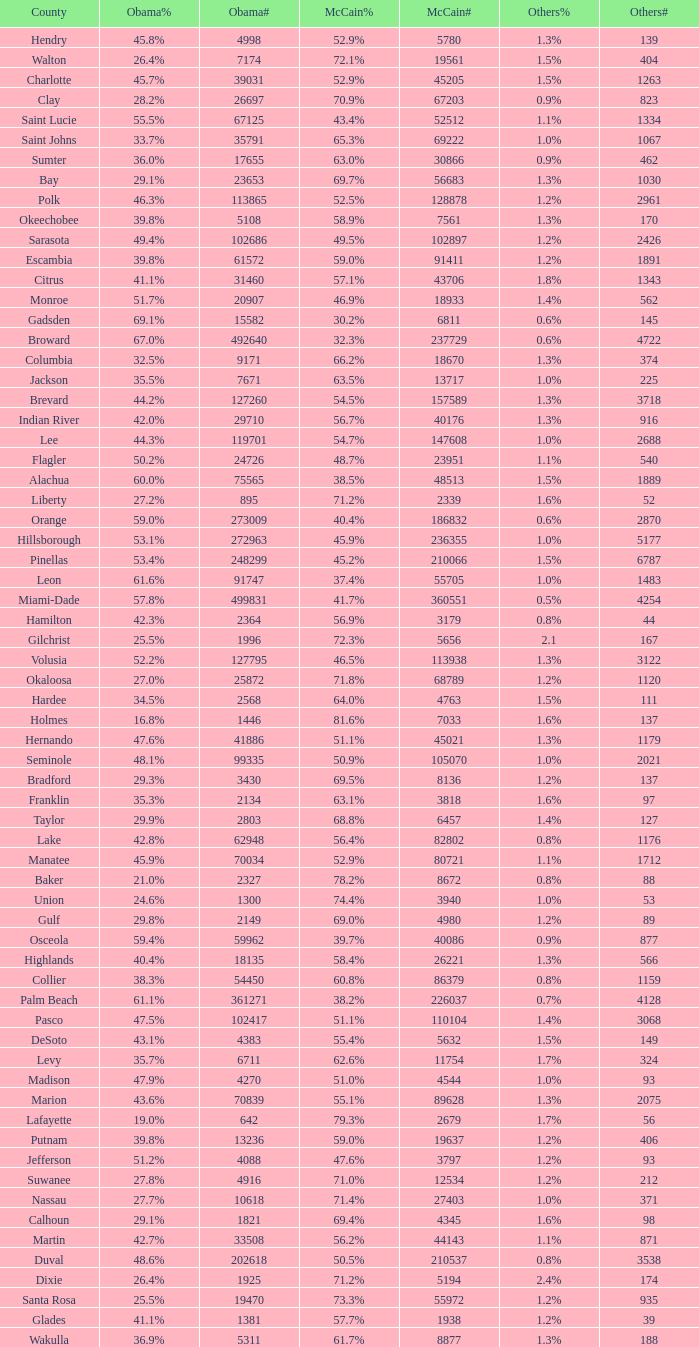What was the number of others votes in Columbia county? 374.0. Could you help me parse every detail presented in this table? {'header': ['County', 'Obama%', 'Obama#', 'McCain%', 'McCain#', 'Others%', 'Others#'], 'rows': [['Hendry', '45.8%', '4998', '52.9%', '5780', '1.3%', '139'], ['Walton', '26.4%', '7174', '72.1%', '19561', '1.5%', '404'], ['Charlotte', '45.7%', '39031', '52.9%', '45205', '1.5%', '1263'], ['Clay', '28.2%', '26697', '70.9%', '67203', '0.9%', '823'], ['Saint Lucie', '55.5%', '67125', '43.4%', '52512', '1.1%', '1334'], ['Saint Johns', '33.7%', '35791', '65.3%', '69222', '1.0%', '1067'], ['Sumter', '36.0%', '17655', '63.0%', '30866', '0.9%', '462'], ['Bay', '29.1%', '23653', '69.7%', '56683', '1.3%', '1030'], ['Polk', '46.3%', '113865', '52.5%', '128878', '1.2%', '2961'], ['Okeechobee', '39.8%', '5108', '58.9%', '7561', '1.3%', '170'], ['Sarasota', '49.4%', '102686', '49.5%', '102897', '1.2%', '2426'], ['Escambia', '39.8%', '61572', '59.0%', '91411', '1.2%', '1891'], ['Citrus', '41.1%', '31460', '57.1%', '43706', '1.8%', '1343'], ['Monroe', '51.7%', '20907', '46.9%', '18933', '1.4%', '562'], ['Gadsden', '69.1%', '15582', '30.2%', '6811', '0.6%', '145'], ['Broward', '67.0%', '492640', '32.3%', '237729', '0.6%', '4722'], ['Columbia', '32.5%', '9171', '66.2%', '18670', '1.3%', '374'], ['Jackson', '35.5%', '7671', '63.5%', '13717', '1.0%', '225'], ['Brevard', '44.2%', '127260', '54.5%', '157589', '1.3%', '3718'], ['Indian River', '42.0%', '29710', '56.7%', '40176', '1.3%', '916'], ['Lee', '44.3%', '119701', '54.7%', '147608', '1.0%', '2688'], ['Flagler', '50.2%', '24726', '48.7%', '23951', '1.1%', '540'], ['Alachua', '60.0%', '75565', '38.5%', '48513', '1.5%', '1889'], ['Liberty', '27.2%', '895', '71.2%', '2339', '1.6%', '52'], ['Orange', '59.0%', '273009', '40.4%', '186832', '0.6%', '2870'], ['Hillsborough', '53.1%', '272963', '45.9%', '236355', '1.0%', '5177'], ['Pinellas', '53.4%', '248299', '45.2%', '210066', '1.5%', '6787'], ['Leon', '61.6%', '91747', '37.4%', '55705', '1.0%', '1483'], ['Miami-Dade', '57.8%', '499831', '41.7%', '360551', '0.5%', '4254'], ['Hamilton', '42.3%', '2364', '56.9%', '3179', '0.8%', '44'], ['Gilchrist', '25.5%', '1996', '72.3%', '5656', '2.1', '167'], ['Volusia', '52.2%', '127795', '46.5%', '113938', '1.3%', '3122'], ['Okaloosa', '27.0%', '25872', '71.8%', '68789', '1.2%', '1120'], ['Hardee', '34.5%', '2568', '64.0%', '4763', '1.5%', '111'], ['Holmes', '16.8%', '1446', '81.6%', '7033', '1.6%', '137'], ['Hernando', '47.6%', '41886', '51.1%', '45021', '1.3%', '1179'], ['Seminole', '48.1%', '99335', '50.9%', '105070', '1.0%', '2021'], ['Bradford', '29.3%', '3430', '69.5%', '8136', '1.2%', '137'], ['Franklin', '35.3%', '2134', '63.1%', '3818', '1.6%', '97'], ['Taylor', '29.9%', '2803', '68.8%', '6457', '1.4%', '127'], ['Lake', '42.8%', '62948', '56.4%', '82802', '0.8%', '1176'], ['Manatee', '45.9%', '70034', '52.9%', '80721', '1.1%', '1712'], ['Baker', '21.0%', '2327', '78.2%', '8672', '0.8%', '88'], ['Union', '24.6%', '1300', '74.4%', '3940', '1.0%', '53'], ['Gulf', '29.8%', '2149', '69.0%', '4980', '1.2%', '89'], ['Osceola', '59.4%', '59962', '39.7%', '40086', '0.9%', '877'], ['Highlands', '40.4%', '18135', '58.4%', '26221', '1.3%', '566'], ['Collier', '38.3%', '54450', '60.8%', '86379', '0.8%', '1159'], ['Palm Beach', '61.1%', '361271', '38.2%', '226037', '0.7%', '4128'], ['Pasco', '47.5%', '102417', '51.1%', '110104', '1.4%', '3068'], ['DeSoto', '43.1%', '4383', '55.4%', '5632', '1.5%', '149'], ['Levy', '35.7%', '6711', '62.6%', '11754', '1.7%', '324'], ['Madison', '47.9%', '4270', '51.0%', '4544', '1.0%', '93'], ['Marion', '43.6%', '70839', '55.1%', '89628', '1.3%', '2075'], ['Lafayette', '19.0%', '642', '79.3%', '2679', '1.7%', '56'], ['Putnam', '39.8%', '13236', '59.0%', '19637', '1.2%', '406'], ['Jefferson', '51.2%', '4088', '47.6%', '3797', '1.2%', '93'], ['Suwanee', '27.8%', '4916', '71.0%', '12534', '1.2%', '212'], ['Nassau', '27.7%', '10618', '71.4%', '27403', '1.0%', '371'], ['Calhoun', '29.1%', '1821', '69.4%', '4345', '1.6%', '98'], ['Martin', '42.7%', '33508', '56.2%', '44143', '1.1%', '871'], ['Duval', '48.6%', '202618', '50.5%', '210537', '0.8%', '3538'], ['Dixie', '26.4%', '1925', '71.2%', '5194', '2.4%', '174'], ['Santa Rosa', '25.5%', '19470', '73.3%', '55972', '1.2%', '935'], ['Glades', '41.1%', '1381', '57.7%', '1938', '1.2%', '39'], ['Wakulla', '36.9%', '5311', '61.7%', '8877', '1.3%', '188']]} 